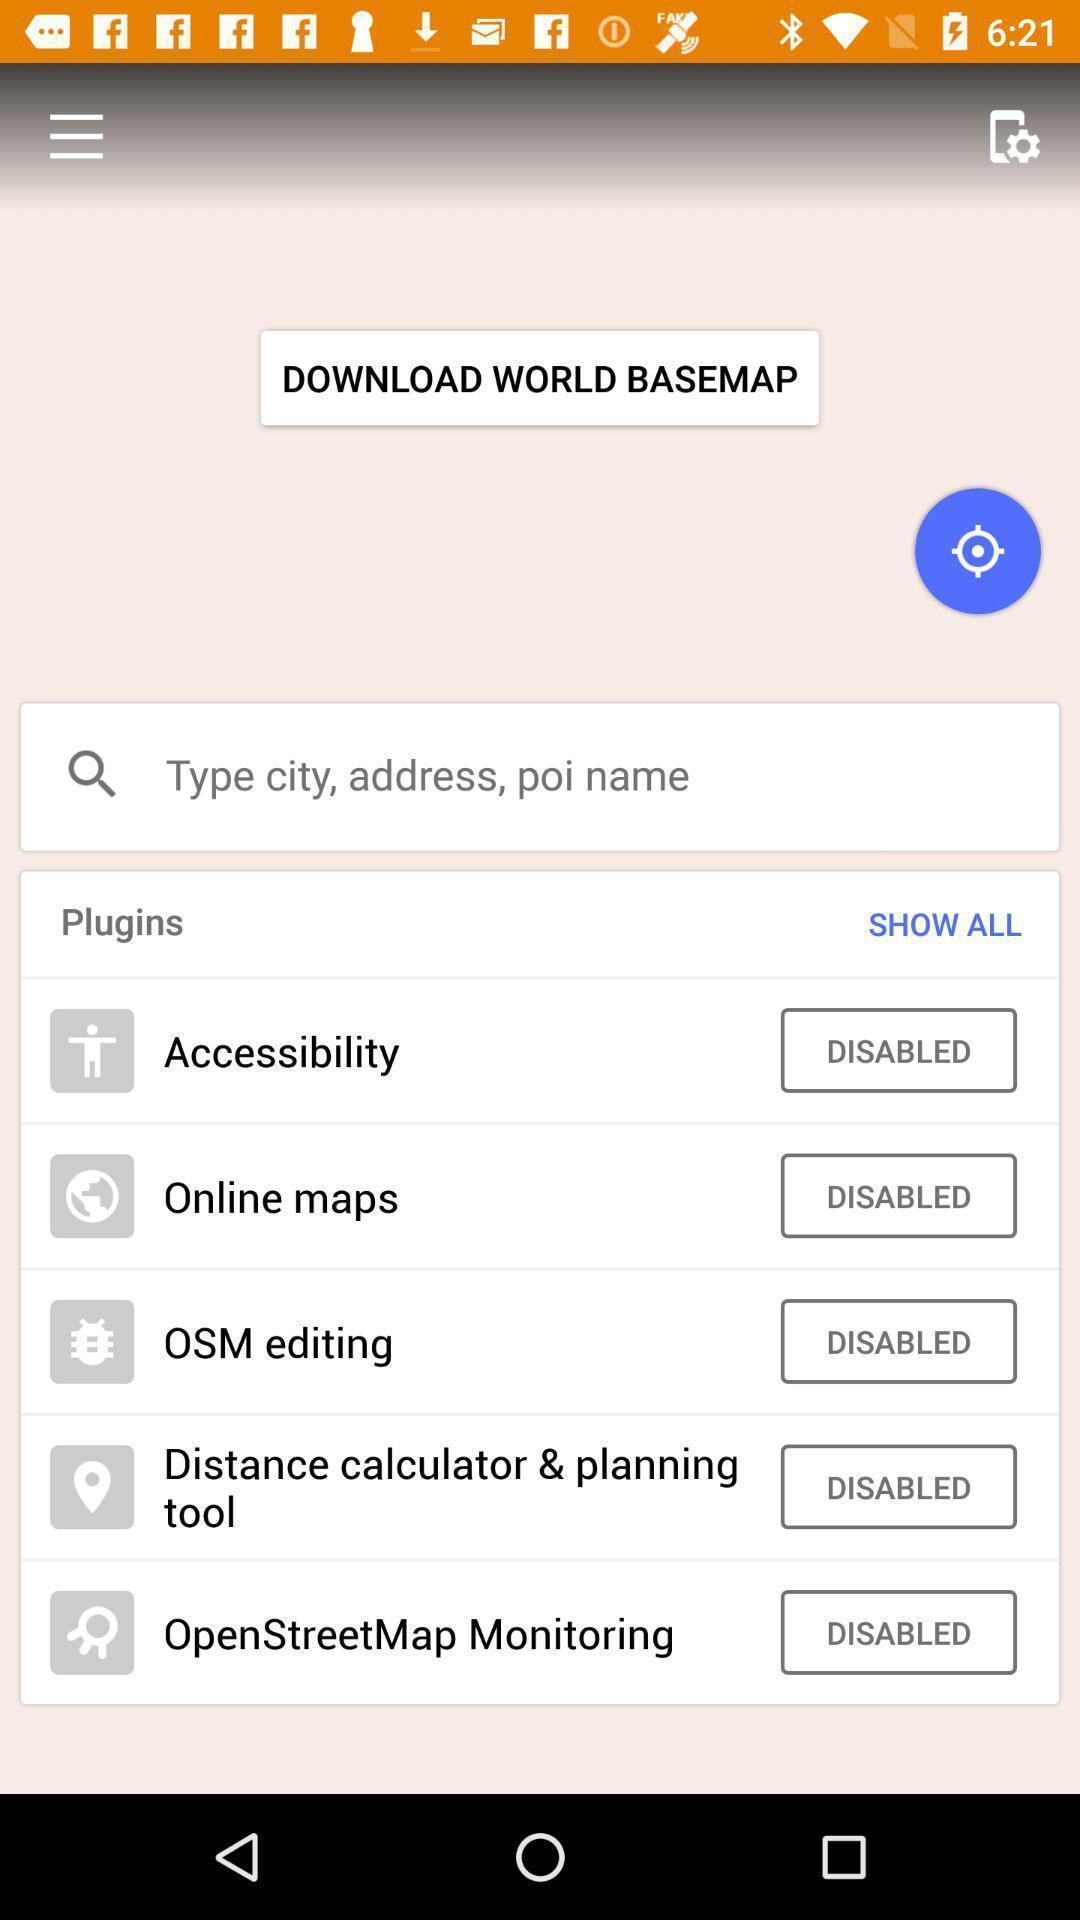Give me a summary of this screen capture. Screen shows different tools in maps. 